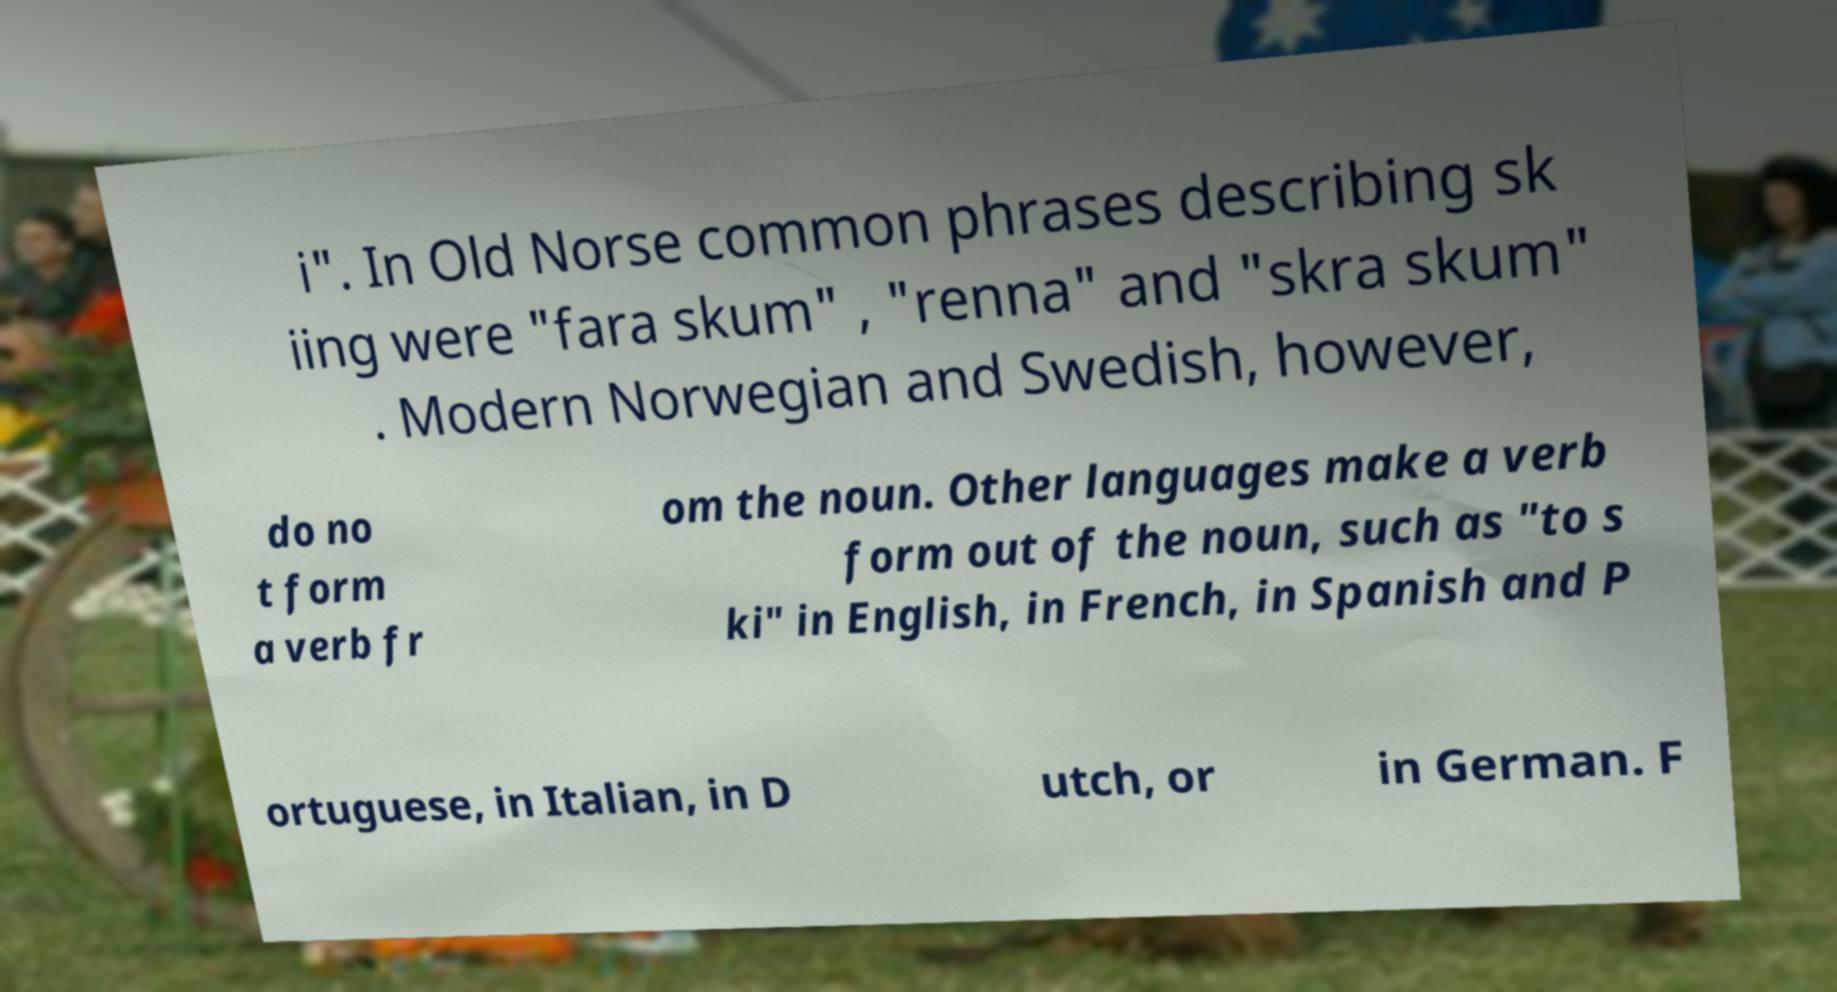Could you extract and type out the text from this image? i". In Old Norse common phrases describing sk iing were "fara skum" , "renna" and "skra skum" . Modern Norwegian and Swedish, however, do no t form a verb fr om the noun. Other languages make a verb form out of the noun, such as "to s ki" in English, in French, in Spanish and P ortuguese, in Italian, in D utch, or in German. F 